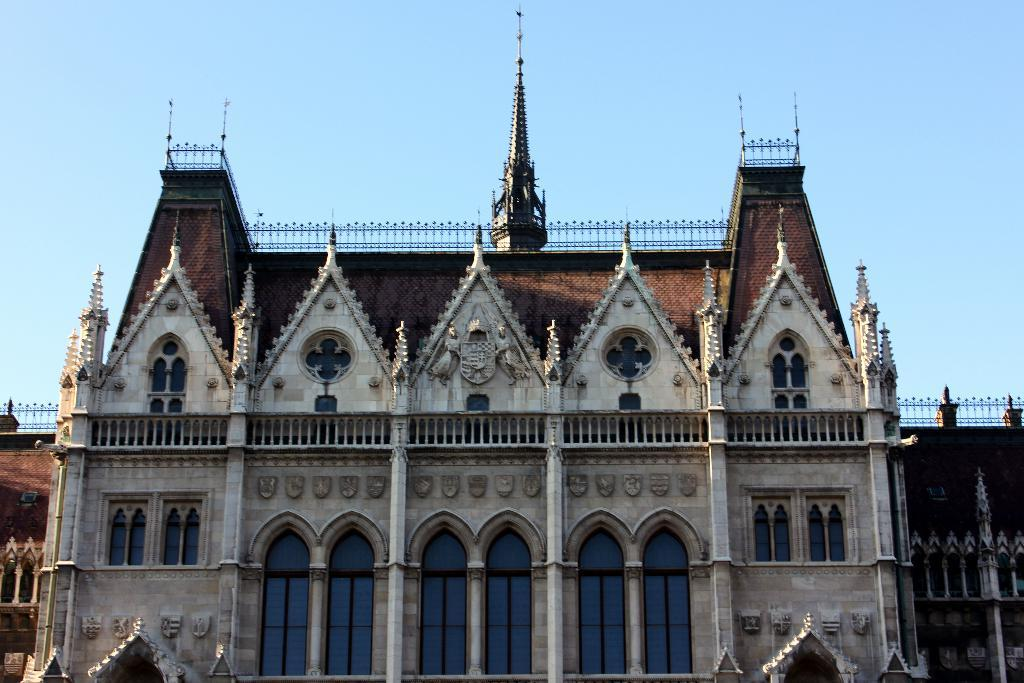What type of structure is visible in the image? There is a building in the image. What architectural features can be seen on the building? The building has arches, pillars, windows, and railings. What can be seen in the background of the image? The sky is visible in the background of the image. What hobbies are the building's inhabitants engaged in within the image? There is no indication of inhabitants or their hobbies in the image; it only shows the building's architectural features and the sky in the background. 